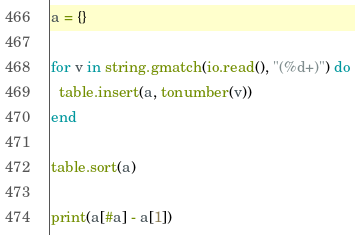<code> <loc_0><loc_0><loc_500><loc_500><_Lua_>a = {}

for v in string.gmatch(io.read(), "(%d+)") do
  table.insert(a, tonumber(v))
end

table.sort(a)

print(a[#a] - a[1])
</code> 